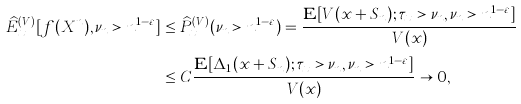<formula> <loc_0><loc_0><loc_500><loc_500>\widehat { E } _ { x } ^ { ( V ) } [ f ( X ^ { n } ) , \nu _ { n } > n ^ { 1 - \varepsilon } ] & \leq \widehat { P } _ { x } ^ { ( V ) } ( \nu _ { n } > n ^ { 1 - \varepsilon } ) = \frac { \mathbf E [ V ( x + S _ { n } ) ; \tau _ { x } > \nu _ { n } , \nu _ { n } > n ^ { 1 - \varepsilon } ] } { V ( x ) } \\ & \leq C \frac { \mathbf E [ \Delta _ { 1 } ( x + S _ { n } ) ; \tau _ { x } > \nu _ { n } , \nu _ { n } > n ^ { 1 - \varepsilon } ] } { V ( x ) } \to 0 ,</formula> 